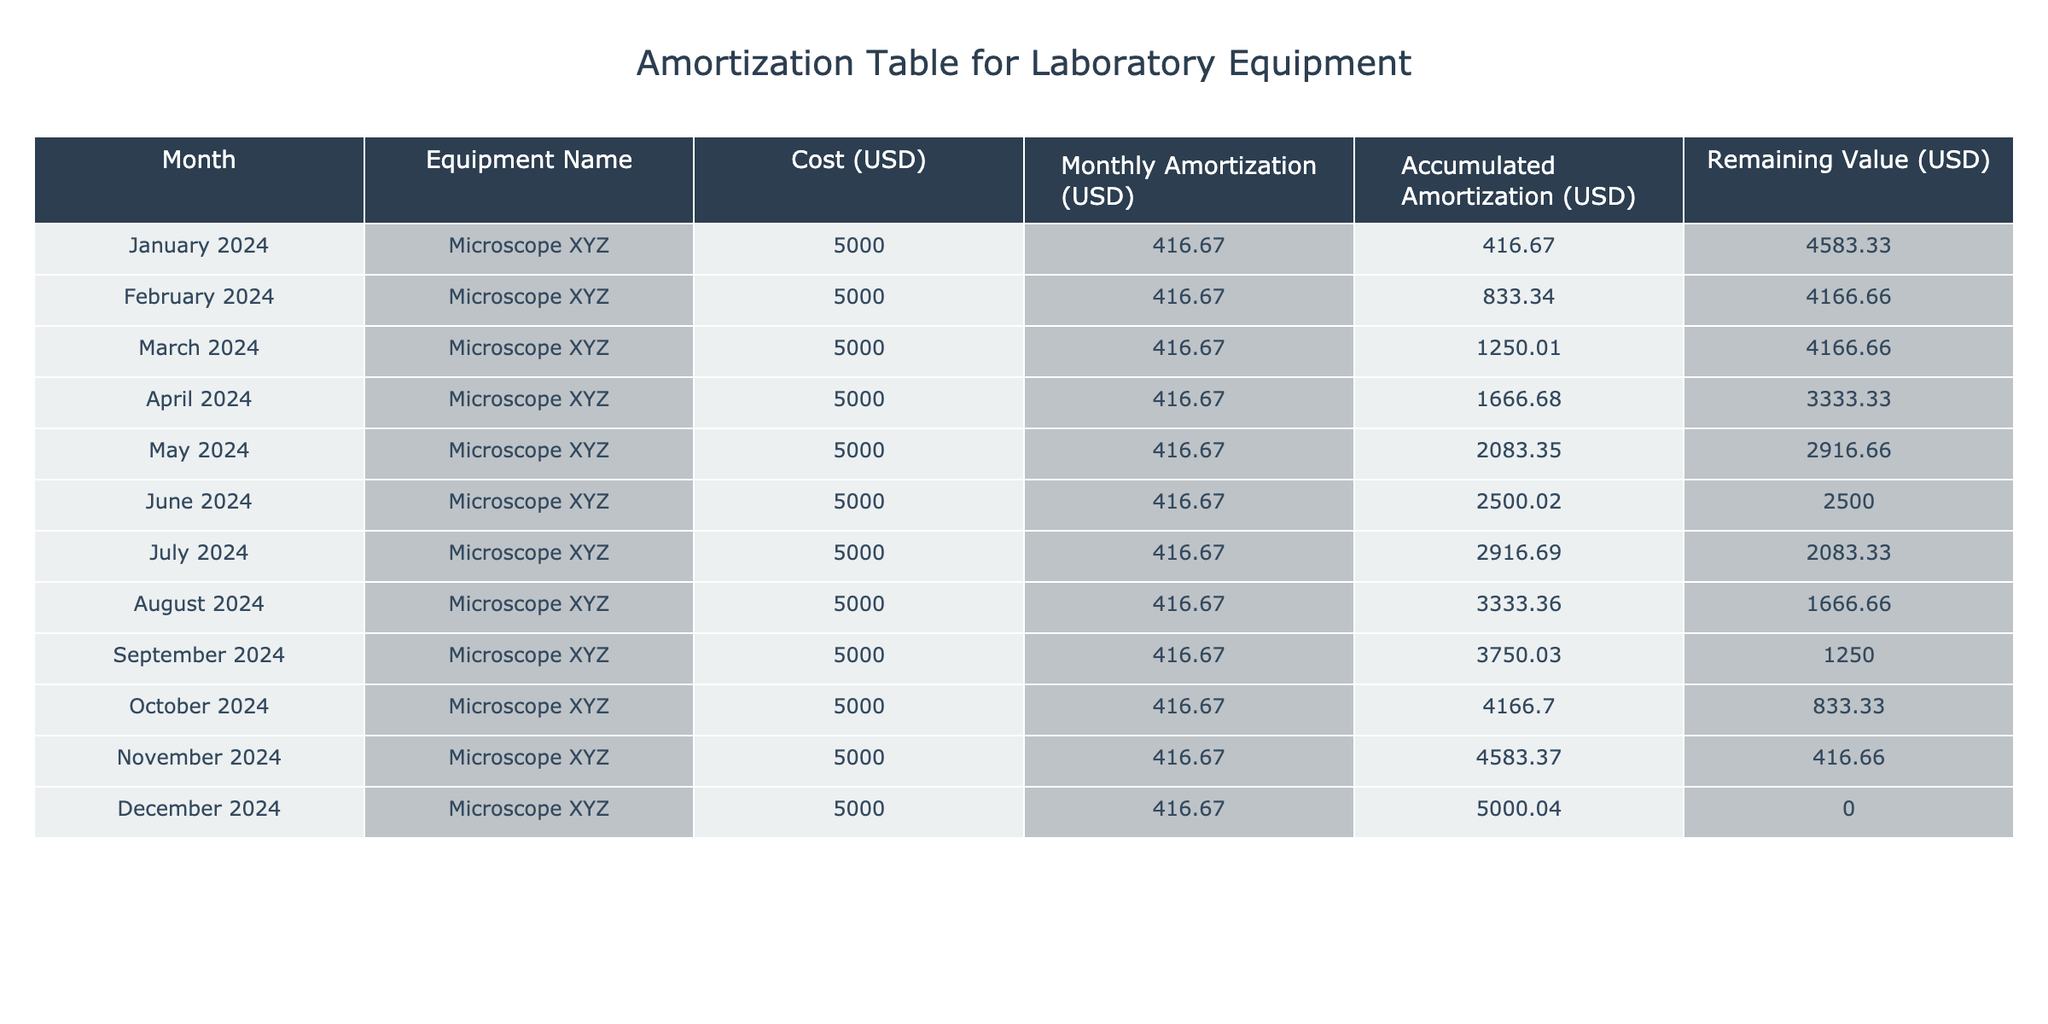What is the total cost of the microscope? The table shows that the cost of the microscope is 5000 USD, which is the same for each month, and since there is only one piece of equipment listed, the total cost remains 5000 USD.
Answer: 5000 USD What is the monthly amortization amount for the microscope? The monthly amortization amount is listed in the table as 416.67 USD for each month. This figure represents the cost allocated to each month for the microscope's usage.
Answer: 416.67 USD What is the accumulated amortization after six months? To find the accumulated amortization for six months, we refer to the table and see that for June 2024, the accumulated amortization is 2500.02 USD. This value reflects the total amortization accrued up to that month.
Answer: 2500.02 USD Is the remaining value of the microscope ever zero before December 2024? By examining the table, the remaining value of the microscope decreases over the months but does not reach zero until December 2024, confirming that it is never zero before that month.
Answer: No What is the difference in accumulated amortization between October and January 2024? The accumulated amortization in October 2024 is 4166.70 USD, and in January 2024, it is 416.67 USD. Calculating the difference: 4166.70 - 416.67 = 3750.03 USD shows the change over that period.
Answer: 3750.03 USD What month has the highest remaining value, and what is that value? The highest remaining value occurs in January 2024, where the remaining value is listed as 4583.33 USD. This is the value before any amortization is accounted for in that month.
Answer: 4583.33 USD What is the total amount of amortization accrued by the end of the year? Looking at the accumulated amortization in December 2024, we see it is equal to 5000.04 USD, which represents the total amount amortized over the entire year of usage.
Answer: 5000.04 USD How much does the remaining value decrease each month? The remaining value decreases consistently by the amount of monthly amortization, which is 416.67 USD each month. The decay is a linear function based on the fixed amortization schedule.
Answer: 416.67 USD In which month does the microscope have a remaining value of 2083.33 USD? According to the table, the remaining value is 2083.33 USD in July 2024, as indicated by the corresponding entry in that month.
Answer: July 2024 